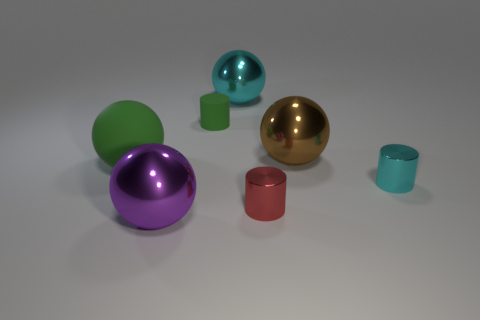What number of large spheres are the same color as the tiny matte cylinder? 1 